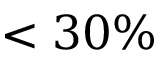<formula> <loc_0><loc_0><loc_500><loc_500>< 3 0 \%</formula> 